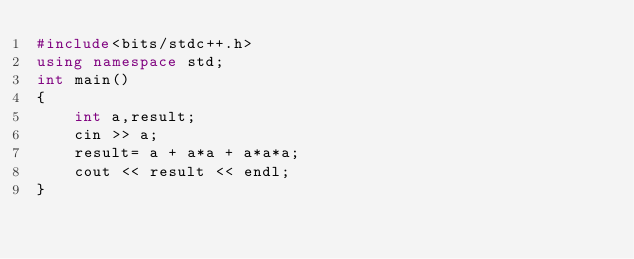<code> <loc_0><loc_0><loc_500><loc_500><_C++_>#include<bits/stdc++.h>
using namespace std;
int main()
{
    int a,result;
    cin >> a;
    result= a + a*a + a*a*a;
    cout << result << endl;
}
</code> 